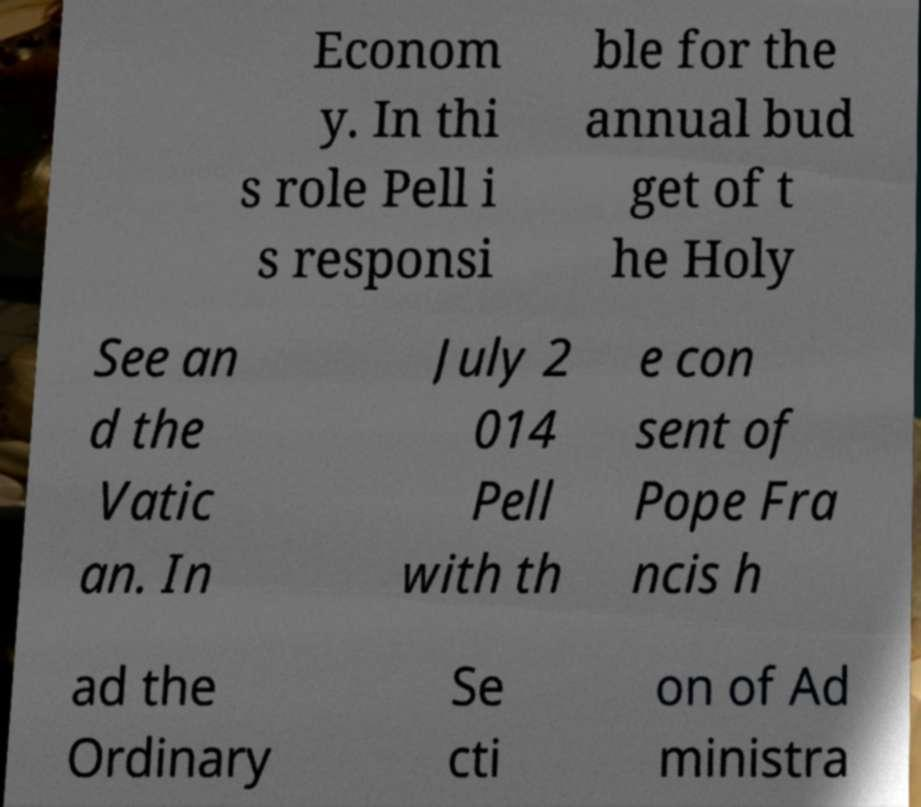Please read and relay the text visible in this image. What does it say? Econom y. In thi s role Pell i s responsi ble for the annual bud get of t he Holy See an d the Vatic an. In July 2 014 Pell with th e con sent of Pope Fra ncis h ad the Ordinary Se cti on of Ad ministra 